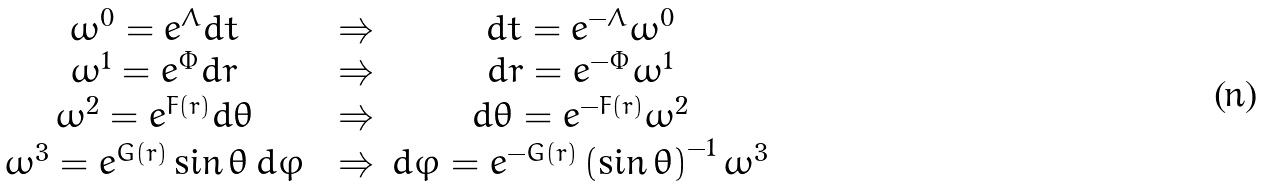Convert formula to latex. <formula><loc_0><loc_0><loc_500><loc_500>\begin{array} { c c c c } \omega ^ { 0 } = e ^ { \Lambda } d t & & \Rightarrow & d t = e ^ { - \Lambda } \omega ^ { 0 } \\ \omega ^ { 1 } = e ^ { \Phi } d r & & \Rightarrow & d r = e ^ { - \Phi } \omega ^ { 1 } \\ \omega ^ { 2 } = e ^ { F \left ( r \right ) } d \theta & & \Rightarrow & d \theta = e ^ { - F \left ( r \right ) } \omega ^ { 2 } \\ \omega ^ { 3 } = e ^ { G \left ( r \right ) } \sin \theta \, d \varphi & & \Rightarrow & d \varphi = e ^ { - G \left ( r \right ) } \left ( \sin \theta \right ) ^ { - 1 } \omega ^ { 3 } \end{array}</formula> 